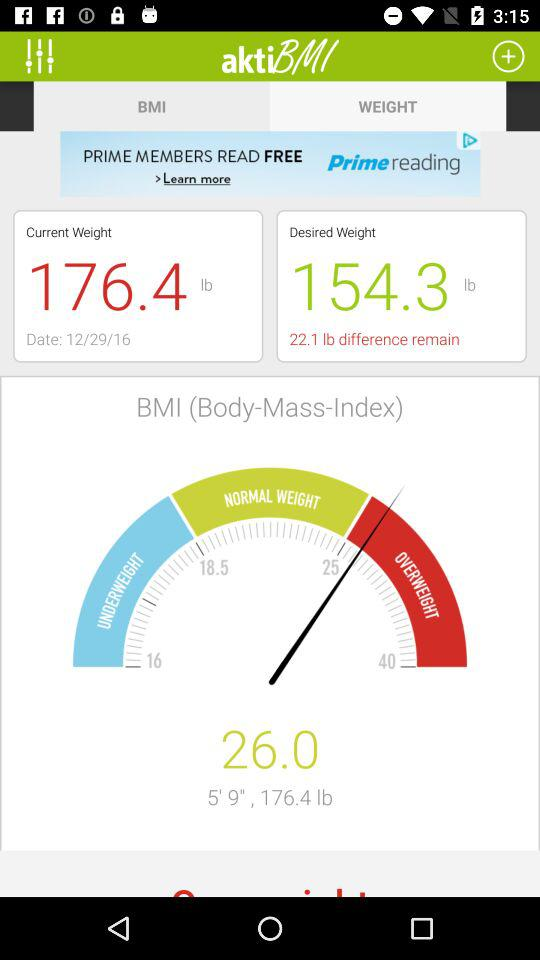How much is the body mass index? The body mass index is 26.0. 